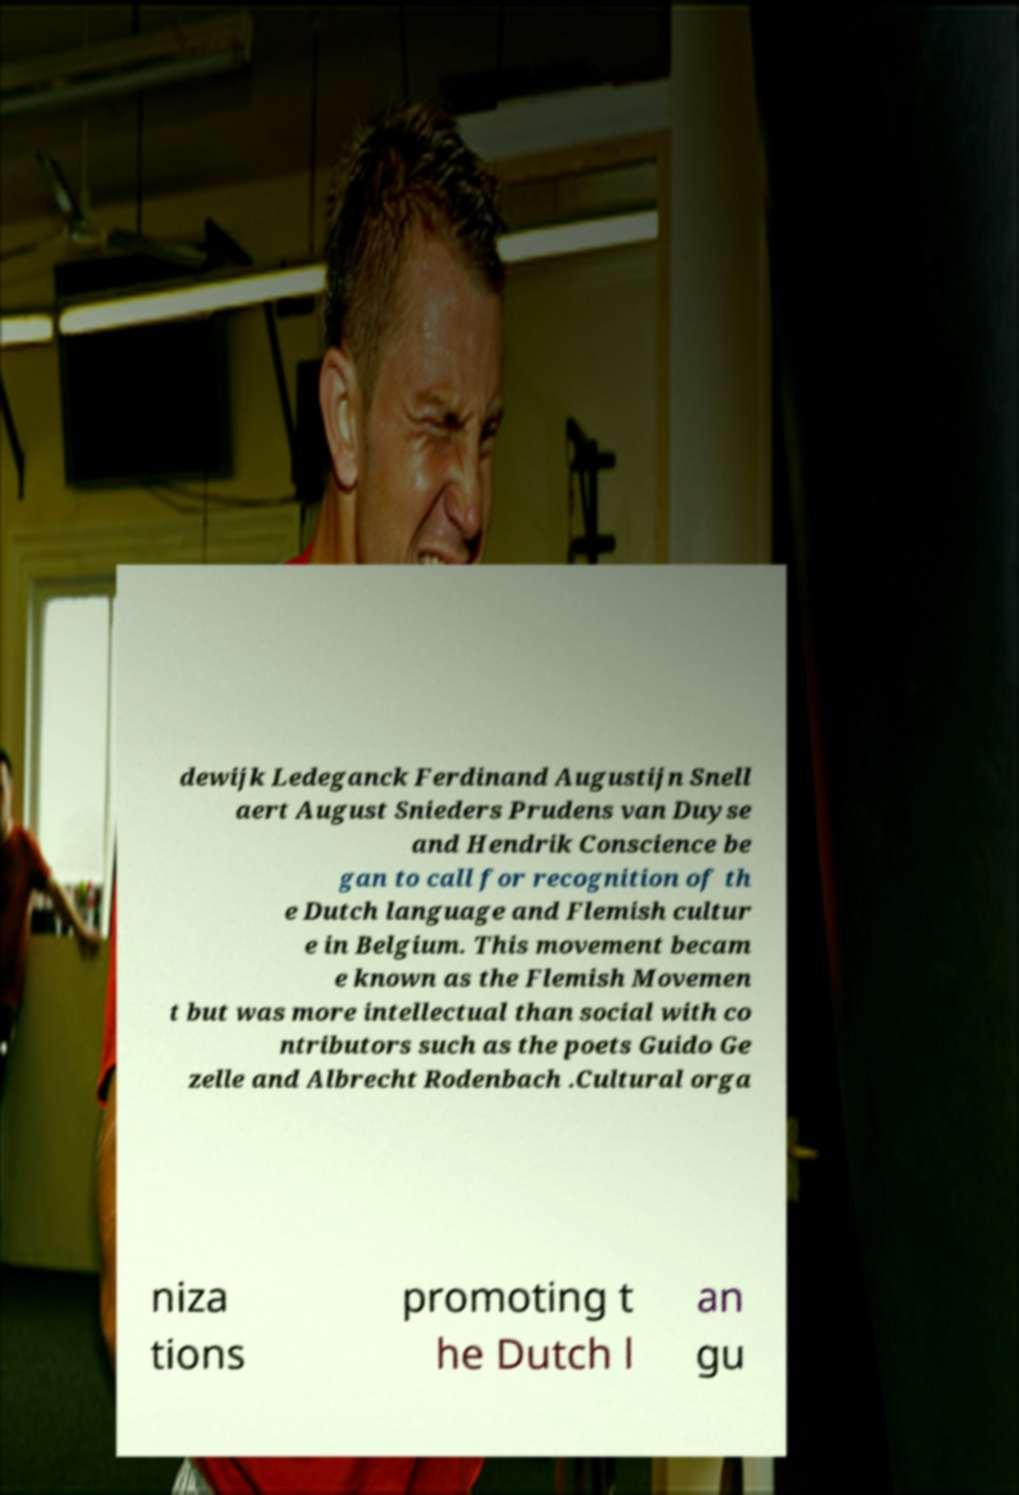Can you read and provide the text displayed in the image?This photo seems to have some interesting text. Can you extract and type it out for me? dewijk Ledeganck Ferdinand Augustijn Snell aert August Snieders Prudens van Duyse and Hendrik Conscience be gan to call for recognition of th e Dutch language and Flemish cultur e in Belgium. This movement becam e known as the Flemish Movemen t but was more intellectual than social with co ntributors such as the poets Guido Ge zelle and Albrecht Rodenbach .Cultural orga niza tions promoting t he Dutch l an gu 